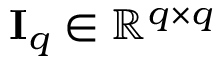<formula> <loc_0><loc_0><loc_500><loc_500>I _ { q } \in \mathbb { R } ^ { q \times q }</formula> 